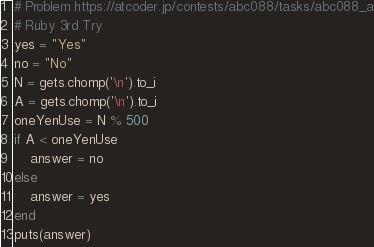<code> <loc_0><loc_0><loc_500><loc_500><_Ruby_># Problem https://atcoder.jp/contests/abc088/tasks/abc088_a
# Ruby 3rd Try
yes = "Yes"
no = "No"
N = gets.chomp('\n').to_i
A = gets.chomp('\n').to_i
oneYenUse = N % 500
if A < oneYenUse
    answer = no
else
    answer = yes    
end
puts(answer)</code> 